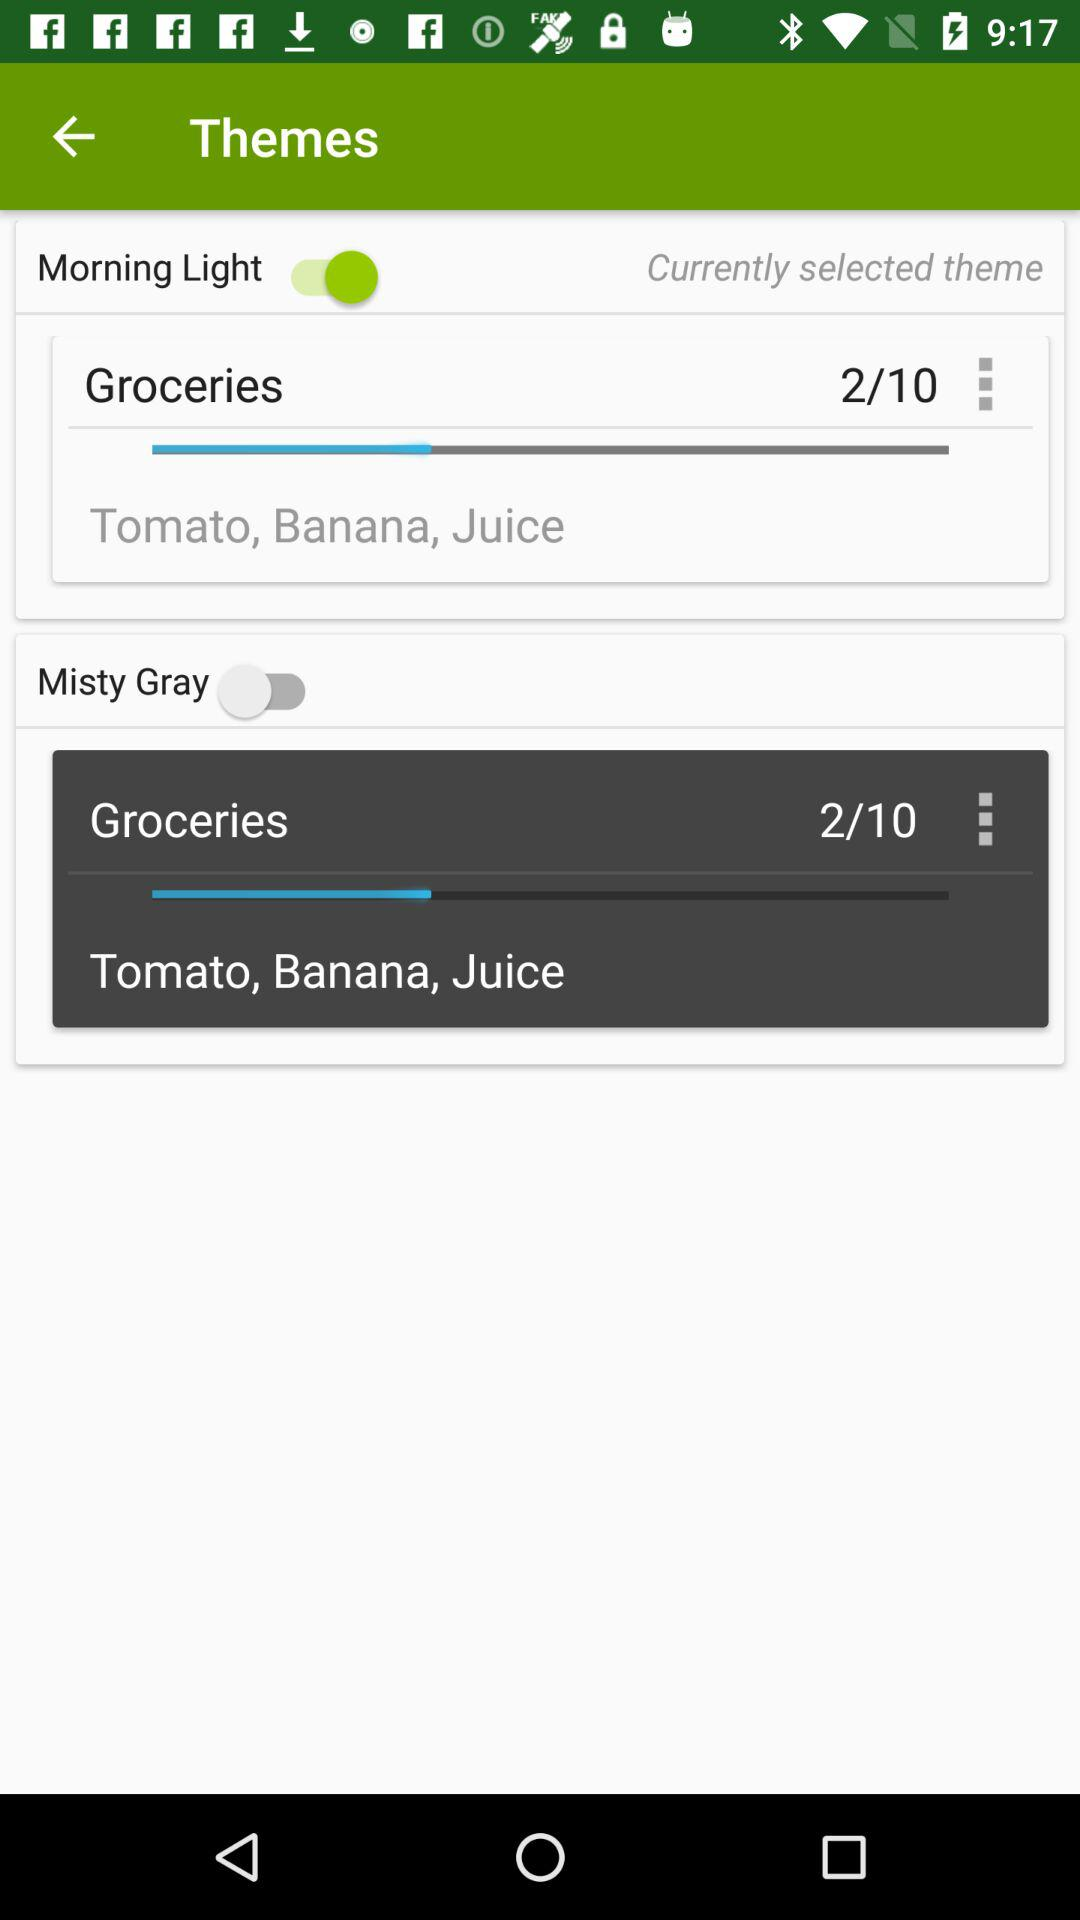What items are in "Groceries"? The items in "Groceries" are tomato, banana, and juice. 